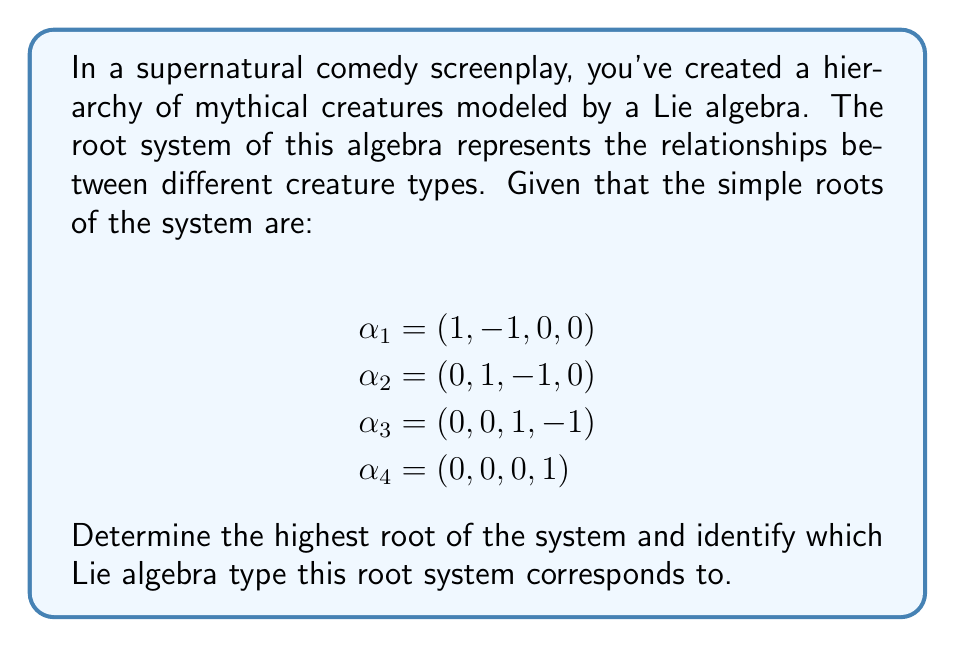Can you solve this math problem? To solve this problem, we'll follow these steps:

1) First, we need to recognize that these simple roots correspond to a rank 4 Lie algebra, as there are 4 simple roots.

2) We can generate all positive roots by taking linear combinations of the simple roots with non-negative integer coefficients. The highest root will be the one with the largest coefficients.

3) Let's start combining the roots:
   $\alpha_1 + \alpha_2 = (1, 0, -1, 0)$
   $\alpha_1 + \alpha_2 + \alpha_3 = (1, 0, 0, -1)$
   $\alpha_2 + \alpha_3 = (0, 1, 0, -1)$

4) Continuing this process, we find that the highest root is:
   $\alpha_1 + \alpha_2 + \alpha_3 + \alpha_4 = (1, 0, 0, 0)$

5) This highest root can be expressed as a linear combination of simple roots:
   $(1, 0, 0, 0) = 1\alpha_1 + 1\alpha_2 + 1\alpha_3 + 1\alpha_4$

6) The coefficients in this linear combination (1, 1, 1, 1) are the marks of the Dynkin diagram.

7) Looking at the structure of the simple roots and the highest root, we can identify this as the root system of the Lie algebra $A_4$.

8) In the context of our supernatural comedy, this $A_4$ structure could represent a strict hierarchy where each creature type (represented by a simple root) has a direct relationship only with the types immediately above and below it in the hierarchy.
Answer: The highest root is $(1, 0, 0, 0)$, which can be expressed as $1\alpha_1 + 1\alpha_2 + 1\alpha_3 + 1\alpha_4$. This root system corresponds to the Lie algebra of type $A_4$. 